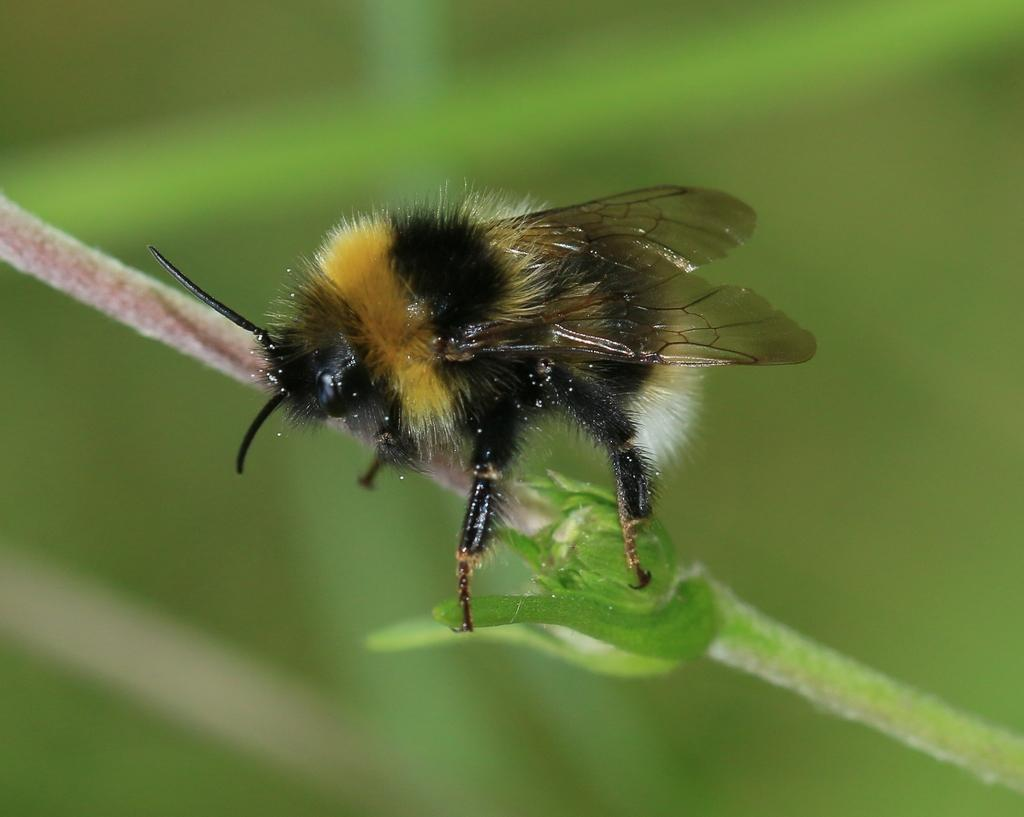What type of creature can be seen in the image? There is an insect in the image. Can you describe the background of the image? The background of the image is blurred. What type of war is depicted in the image? There is no war depicted in the image; it features an insect and a blurred background. Can you describe the fog in the image? There is no fog present in the image; the background is simply blurred. 